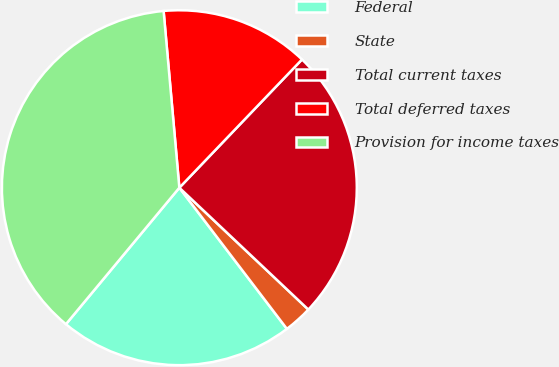Convert chart to OTSL. <chart><loc_0><loc_0><loc_500><loc_500><pie_chart><fcel>Federal<fcel>State<fcel>Total current taxes<fcel>Total deferred taxes<fcel>Provision for income taxes<nl><fcel>21.4%<fcel>2.59%<fcel>24.9%<fcel>13.56%<fcel>37.55%<nl></chart> 